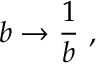<formula> <loc_0><loc_0><loc_500><loc_500>b \to { \frac { 1 } { b } } \ ,</formula> 